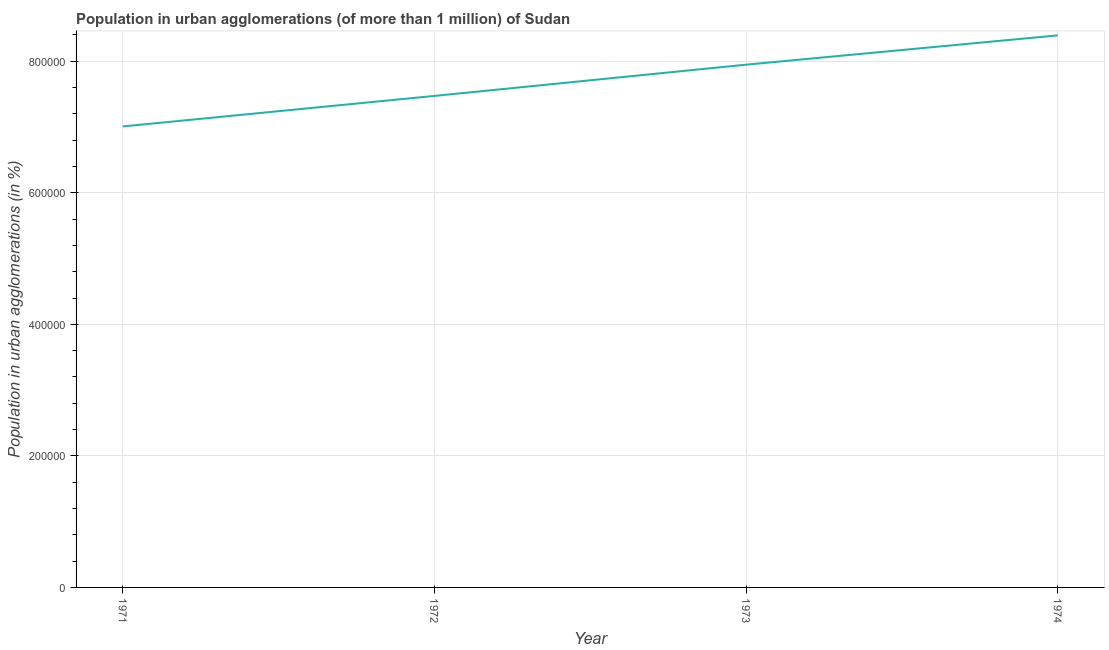What is the population in urban agglomerations in 1973?
Offer a very short reply. 7.95e+05. Across all years, what is the maximum population in urban agglomerations?
Give a very brief answer. 8.39e+05. Across all years, what is the minimum population in urban agglomerations?
Provide a short and direct response. 7.01e+05. In which year was the population in urban agglomerations maximum?
Offer a terse response. 1974. In which year was the population in urban agglomerations minimum?
Offer a terse response. 1971. What is the sum of the population in urban agglomerations?
Provide a succinct answer. 3.08e+06. What is the difference between the population in urban agglomerations in 1972 and 1973?
Provide a succinct answer. -4.75e+04. What is the average population in urban agglomerations per year?
Your response must be concise. 7.71e+05. What is the median population in urban agglomerations?
Make the answer very short. 7.71e+05. What is the ratio of the population in urban agglomerations in 1972 to that in 1973?
Your response must be concise. 0.94. Is the population in urban agglomerations in 1972 less than that in 1973?
Your answer should be very brief. Yes. Is the difference between the population in urban agglomerations in 1971 and 1973 greater than the difference between any two years?
Your response must be concise. No. What is the difference between the highest and the second highest population in urban agglomerations?
Ensure brevity in your answer.  4.45e+04. Is the sum of the population in urban agglomerations in 1971 and 1974 greater than the maximum population in urban agglomerations across all years?
Offer a very short reply. Yes. What is the difference between the highest and the lowest population in urban agglomerations?
Keep it short and to the point. 1.38e+05. How many years are there in the graph?
Make the answer very short. 4. What is the difference between two consecutive major ticks on the Y-axis?
Your answer should be compact. 2.00e+05. Are the values on the major ticks of Y-axis written in scientific E-notation?
Keep it short and to the point. No. Does the graph contain any zero values?
Your answer should be compact. No. What is the title of the graph?
Your answer should be very brief. Population in urban agglomerations (of more than 1 million) of Sudan. What is the label or title of the X-axis?
Offer a terse response. Year. What is the label or title of the Y-axis?
Offer a terse response. Population in urban agglomerations (in %). What is the Population in urban agglomerations (in %) in 1971?
Your answer should be compact. 7.01e+05. What is the Population in urban agglomerations (in %) of 1972?
Your answer should be very brief. 7.47e+05. What is the Population in urban agglomerations (in %) of 1973?
Make the answer very short. 7.95e+05. What is the Population in urban agglomerations (in %) in 1974?
Your response must be concise. 8.39e+05. What is the difference between the Population in urban agglomerations (in %) in 1971 and 1972?
Your answer should be compact. -4.64e+04. What is the difference between the Population in urban agglomerations (in %) in 1971 and 1973?
Your answer should be very brief. -9.39e+04. What is the difference between the Population in urban agglomerations (in %) in 1971 and 1974?
Your answer should be compact. -1.38e+05. What is the difference between the Population in urban agglomerations (in %) in 1972 and 1973?
Make the answer very short. -4.75e+04. What is the difference between the Population in urban agglomerations (in %) in 1972 and 1974?
Your answer should be very brief. -9.20e+04. What is the difference between the Population in urban agglomerations (in %) in 1973 and 1974?
Offer a terse response. -4.45e+04. What is the ratio of the Population in urban agglomerations (in %) in 1971 to that in 1972?
Make the answer very short. 0.94. What is the ratio of the Population in urban agglomerations (in %) in 1971 to that in 1973?
Offer a very short reply. 0.88. What is the ratio of the Population in urban agglomerations (in %) in 1971 to that in 1974?
Your answer should be compact. 0.83. What is the ratio of the Population in urban agglomerations (in %) in 1972 to that in 1973?
Offer a terse response. 0.94. What is the ratio of the Population in urban agglomerations (in %) in 1972 to that in 1974?
Make the answer very short. 0.89. What is the ratio of the Population in urban agglomerations (in %) in 1973 to that in 1974?
Give a very brief answer. 0.95. 